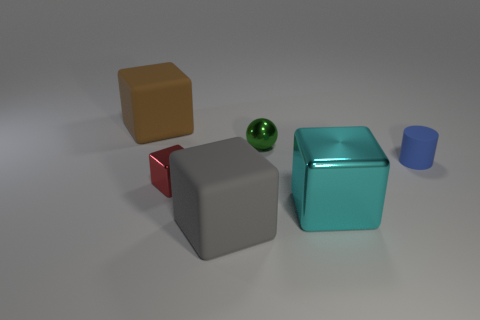There is a cylinder that is the same size as the green object; what color is it?
Give a very brief answer. Blue. There is a large object that is behind the blue cylinder; how many big rubber blocks are behind it?
Give a very brief answer. 0. How many objects are both behind the cyan cube and in front of the small red cube?
Provide a short and direct response. 0. What number of things are either cubes to the right of the brown object or brown objects that are behind the cylinder?
Make the answer very short. 4. What number of other things are the same size as the brown rubber cube?
Your answer should be compact. 2. There is a big matte thing that is on the right side of the matte block to the left of the large gray rubber cube; what shape is it?
Offer a very short reply. Cube. Is the color of the shiny object that is behind the small blue rubber object the same as the matte cube in front of the brown thing?
Your answer should be very brief. No. Is there anything else of the same color as the big metal block?
Offer a very short reply. No. The small shiny block is what color?
Offer a terse response. Red. Are any big blue shiny cylinders visible?
Ensure brevity in your answer.  No. 